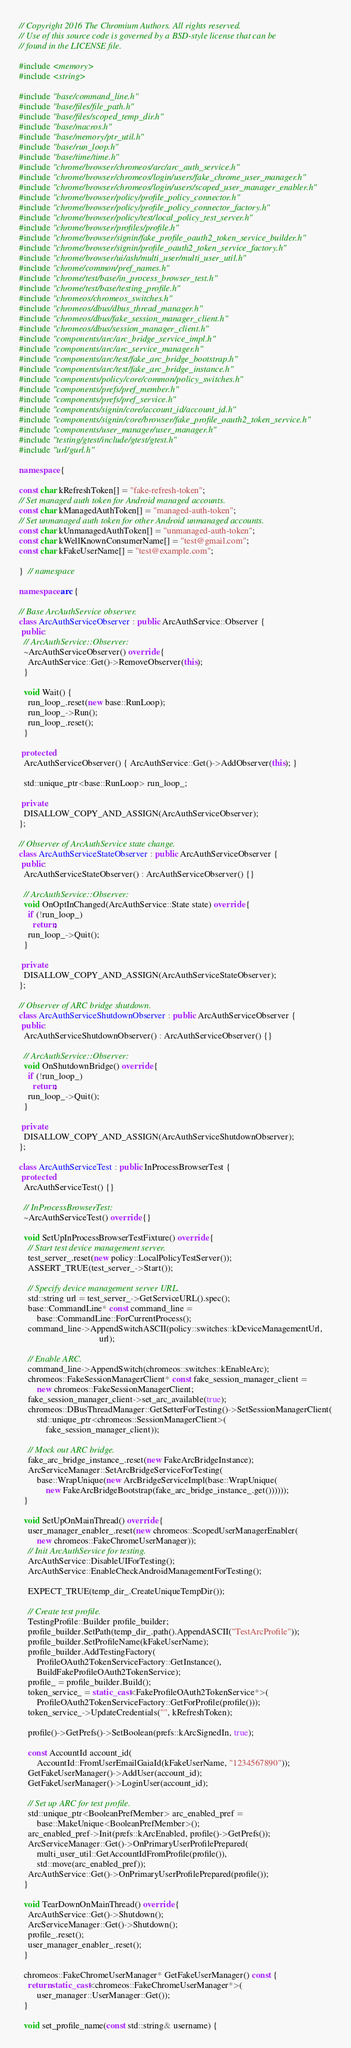<code> <loc_0><loc_0><loc_500><loc_500><_C++_>// Copyright 2016 The Chromium Authors. All rights reserved.
// Use of this source code is governed by a BSD-style license that can be
// found in the LICENSE file.

#include <memory>
#include <string>

#include "base/command_line.h"
#include "base/files/file_path.h"
#include "base/files/scoped_temp_dir.h"
#include "base/macros.h"
#include "base/memory/ptr_util.h"
#include "base/run_loop.h"
#include "base/time/time.h"
#include "chrome/browser/chromeos/arc/arc_auth_service.h"
#include "chrome/browser/chromeos/login/users/fake_chrome_user_manager.h"
#include "chrome/browser/chromeos/login/users/scoped_user_manager_enabler.h"
#include "chrome/browser/policy/profile_policy_connector.h"
#include "chrome/browser/policy/profile_policy_connector_factory.h"
#include "chrome/browser/policy/test/local_policy_test_server.h"
#include "chrome/browser/profiles/profile.h"
#include "chrome/browser/signin/fake_profile_oauth2_token_service_builder.h"
#include "chrome/browser/signin/profile_oauth2_token_service_factory.h"
#include "chrome/browser/ui/ash/multi_user/multi_user_util.h"
#include "chrome/common/pref_names.h"
#include "chrome/test/base/in_process_browser_test.h"
#include "chrome/test/base/testing_profile.h"
#include "chromeos/chromeos_switches.h"
#include "chromeos/dbus/dbus_thread_manager.h"
#include "chromeos/dbus/fake_session_manager_client.h"
#include "chromeos/dbus/session_manager_client.h"
#include "components/arc/arc_bridge_service_impl.h"
#include "components/arc/arc_service_manager.h"
#include "components/arc/test/fake_arc_bridge_bootstrap.h"
#include "components/arc/test/fake_arc_bridge_instance.h"
#include "components/policy/core/common/policy_switches.h"
#include "components/prefs/pref_member.h"
#include "components/prefs/pref_service.h"
#include "components/signin/core/account_id/account_id.h"
#include "components/signin/core/browser/fake_profile_oauth2_token_service.h"
#include "components/user_manager/user_manager.h"
#include "testing/gtest/include/gtest/gtest.h"
#include "url/gurl.h"

namespace {

const char kRefreshToken[] = "fake-refresh-token";
// Set managed auth token for Android managed accounts.
const char kManagedAuthToken[] = "managed-auth-token";
// Set unmanaged auth token for other Android unmanaged accounts.
const char kUnmanagedAuthToken[] = "unmanaged-auth-token";
const char kWellKnownConsumerName[] = "test@gmail.com";
const char kFakeUserName[] = "test@example.com";

}  // namespace

namespace arc {

// Base ArcAuthService observer.
class ArcAuthServiceObserver : public ArcAuthService::Observer {
 public:
  // ArcAuthService::Observer:
  ~ArcAuthServiceObserver() override {
    ArcAuthService::Get()->RemoveObserver(this);
  }

  void Wait() {
    run_loop_.reset(new base::RunLoop);
    run_loop_->Run();
    run_loop_.reset();
  }

 protected:
  ArcAuthServiceObserver() { ArcAuthService::Get()->AddObserver(this); }

  std::unique_ptr<base::RunLoop> run_loop_;

 private:
  DISALLOW_COPY_AND_ASSIGN(ArcAuthServiceObserver);
};

// Observer of ArcAuthService state change.
class ArcAuthServiceStateObserver : public ArcAuthServiceObserver {
 public:
  ArcAuthServiceStateObserver() : ArcAuthServiceObserver() {}

  // ArcAuthService::Observer:
  void OnOptInChanged(ArcAuthService::State state) override {
    if (!run_loop_)
      return;
    run_loop_->Quit();
  }

 private:
  DISALLOW_COPY_AND_ASSIGN(ArcAuthServiceStateObserver);
};

// Observer of ARC bridge shutdown.
class ArcAuthServiceShutdownObserver : public ArcAuthServiceObserver {
 public:
  ArcAuthServiceShutdownObserver() : ArcAuthServiceObserver() {}

  // ArcAuthService::Observer:
  void OnShutdownBridge() override {
    if (!run_loop_)
      return;
    run_loop_->Quit();
  }

 private:
  DISALLOW_COPY_AND_ASSIGN(ArcAuthServiceShutdownObserver);
};

class ArcAuthServiceTest : public InProcessBrowserTest {
 protected:
  ArcAuthServiceTest() {}

  // InProcessBrowserTest:
  ~ArcAuthServiceTest() override {}

  void SetUpInProcessBrowserTestFixture() override {
    // Start test device management server.
    test_server_.reset(new policy::LocalPolicyTestServer());
    ASSERT_TRUE(test_server_->Start());

    // Specify device management server URL.
    std::string url = test_server_->GetServiceURL().spec();
    base::CommandLine* const command_line =
        base::CommandLine::ForCurrentProcess();
    command_line->AppendSwitchASCII(policy::switches::kDeviceManagementUrl,
                                    url);

    // Enable ARC.
    command_line->AppendSwitch(chromeos::switches::kEnableArc);
    chromeos::FakeSessionManagerClient* const fake_session_manager_client =
        new chromeos::FakeSessionManagerClient;
    fake_session_manager_client->set_arc_available(true);
    chromeos::DBusThreadManager::GetSetterForTesting()->SetSessionManagerClient(
        std::unique_ptr<chromeos::SessionManagerClient>(
            fake_session_manager_client));

    // Mock out ARC bridge.
    fake_arc_bridge_instance_.reset(new FakeArcBridgeInstance);
    ArcServiceManager::SetArcBridgeServiceForTesting(
        base::WrapUnique(new ArcBridgeServiceImpl(base::WrapUnique(
            new FakeArcBridgeBootstrap(fake_arc_bridge_instance_.get())))));
  }

  void SetUpOnMainThread() override {
    user_manager_enabler_.reset(new chromeos::ScopedUserManagerEnabler(
        new chromeos::FakeChromeUserManager));
    // Init ArcAuthService for testing.
    ArcAuthService::DisableUIForTesting();
    ArcAuthService::EnableCheckAndroidManagementForTesting();

    EXPECT_TRUE(temp_dir_.CreateUniqueTempDir());

    // Create test profile.
    TestingProfile::Builder profile_builder;
    profile_builder.SetPath(temp_dir_.path().AppendASCII("TestArcProfile"));
    profile_builder.SetProfileName(kFakeUserName);
    profile_builder.AddTestingFactory(
        ProfileOAuth2TokenServiceFactory::GetInstance(),
        BuildFakeProfileOAuth2TokenService);
    profile_ = profile_builder.Build();
    token_service_ = static_cast<FakeProfileOAuth2TokenService*>(
        ProfileOAuth2TokenServiceFactory::GetForProfile(profile()));
    token_service_->UpdateCredentials("", kRefreshToken);

    profile()->GetPrefs()->SetBoolean(prefs::kArcSignedIn, true);

    const AccountId account_id(
        AccountId::FromUserEmailGaiaId(kFakeUserName, "1234567890"));
    GetFakeUserManager()->AddUser(account_id);
    GetFakeUserManager()->LoginUser(account_id);

    // Set up ARC for test profile.
    std::unique_ptr<BooleanPrefMember> arc_enabled_pref =
        base::MakeUnique<BooleanPrefMember>();
    arc_enabled_pref->Init(prefs::kArcEnabled, profile()->GetPrefs());
    ArcServiceManager::Get()->OnPrimaryUserProfilePrepared(
        multi_user_util::GetAccountIdFromProfile(profile()),
        std::move(arc_enabled_pref));
    ArcAuthService::Get()->OnPrimaryUserProfilePrepared(profile());
  }

  void TearDownOnMainThread() override {
    ArcAuthService::Get()->Shutdown();
    ArcServiceManager::Get()->Shutdown();
    profile_.reset();
    user_manager_enabler_.reset();
  }

  chromeos::FakeChromeUserManager* GetFakeUserManager() const {
    return static_cast<chromeos::FakeChromeUserManager*>(
        user_manager::UserManager::Get());
  }

  void set_profile_name(const std::string& username) {</code> 